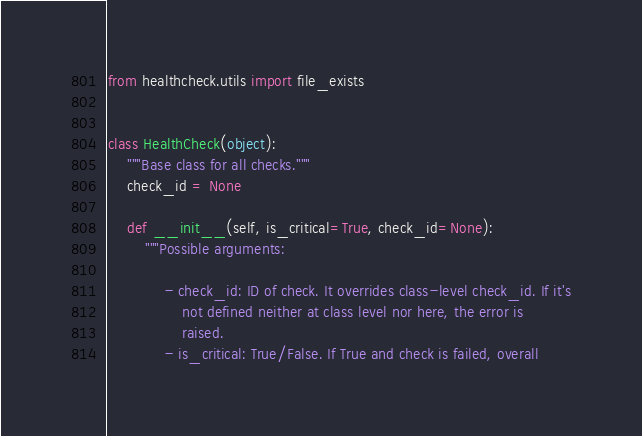Convert code to text. <code><loc_0><loc_0><loc_500><loc_500><_Python_>from healthcheck.utils import file_exists


class HealthCheck(object):
    """Base class for all checks."""
    check_id = None

    def __init__(self, is_critical=True, check_id=None):
        """Possible arguments:

            - check_id: ID of check. It overrides class-level check_id. If it's
                not defined neither at class level nor here, the error is
                raised.
            - is_critical: True/False. If True and check is failed, overall</code> 